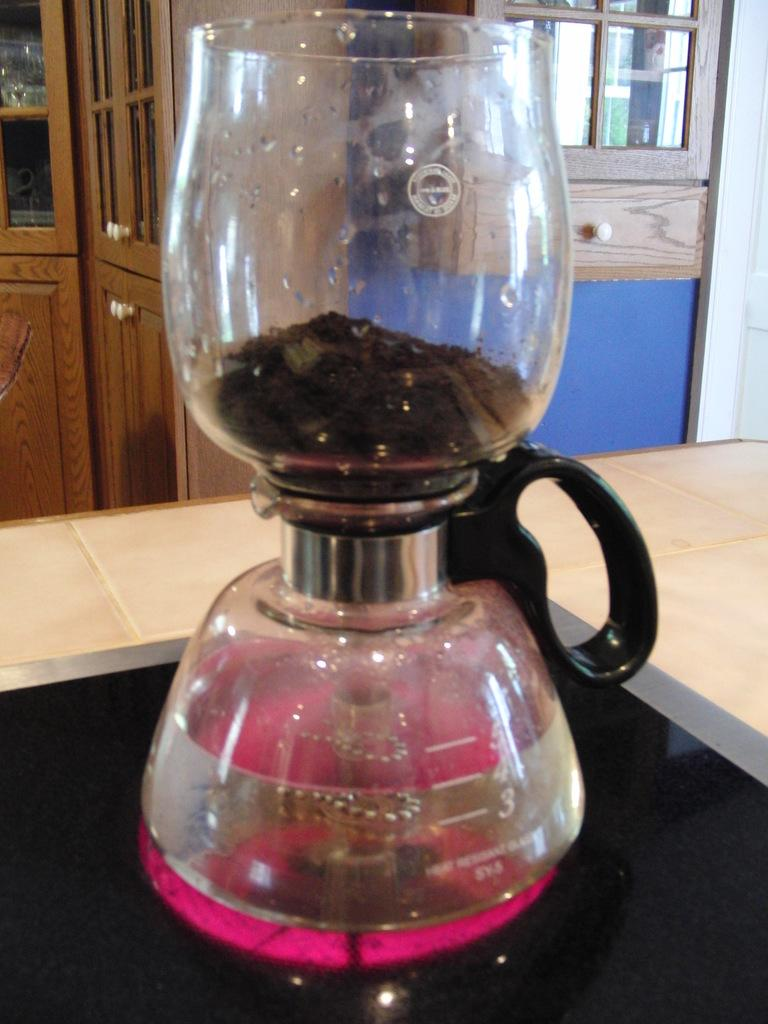<image>
Create a compact narrative representing the image presented. A glass water container on the stove is filled with water up to the number 4 with some other glass item on top of it. 